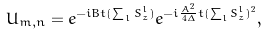<formula> <loc_0><loc_0><loc_500><loc_500>U _ { m , n } = e ^ { - i B t ( \sum _ { l } S ^ { l } _ { z } ) } e ^ { - i \frac { A ^ { 2 } } { 4 \Delta } t ( \sum _ { l } S ^ { l } _ { z } ) ^ { 2 } } ,</formula> 